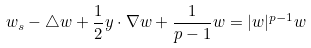Convert formula to latex. <formula><loc_0><loc_0><loc_500><loc_500>w _ { s } - \triangle w + \frac { 1 } { 2 } y \cdot \nabla w + \frac { 1 } { p - 1 } w = | w | ^ { p - 1 } w</formula> 